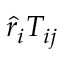<formula> <loc_0><loc_0><loc_500><loc_500>\hat { r } _ { i } T _ { i j }</formula> 